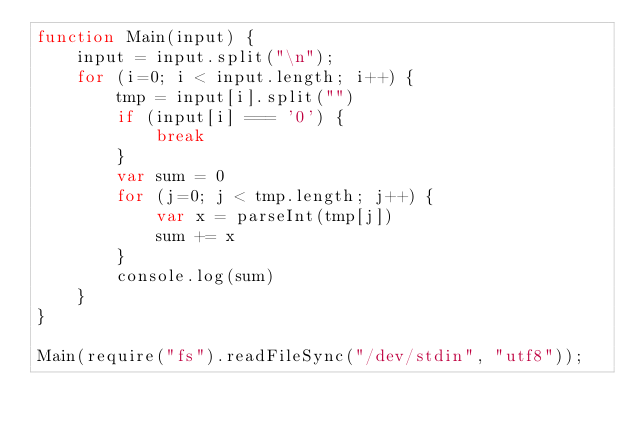Convert code to text. <code><loc_0><loc_0><loc_500><loc_500><_JavaScript_>function Main(input) {
    input = input.split("\n");
    for (i=0; i < input.length; i++) {
        tmp = input[i].split("")
        if (input[i] === '0') {
            break
        }
        var sum = 0
        for (j=0; j < tmp.length; j++) {
            var x = parseInt(tmp[j])
            sum += x
        }
        console.log(sum)
    }
}

Main(require("fs").readFileSync("/dev/stdin", "utf8"));

</code> 